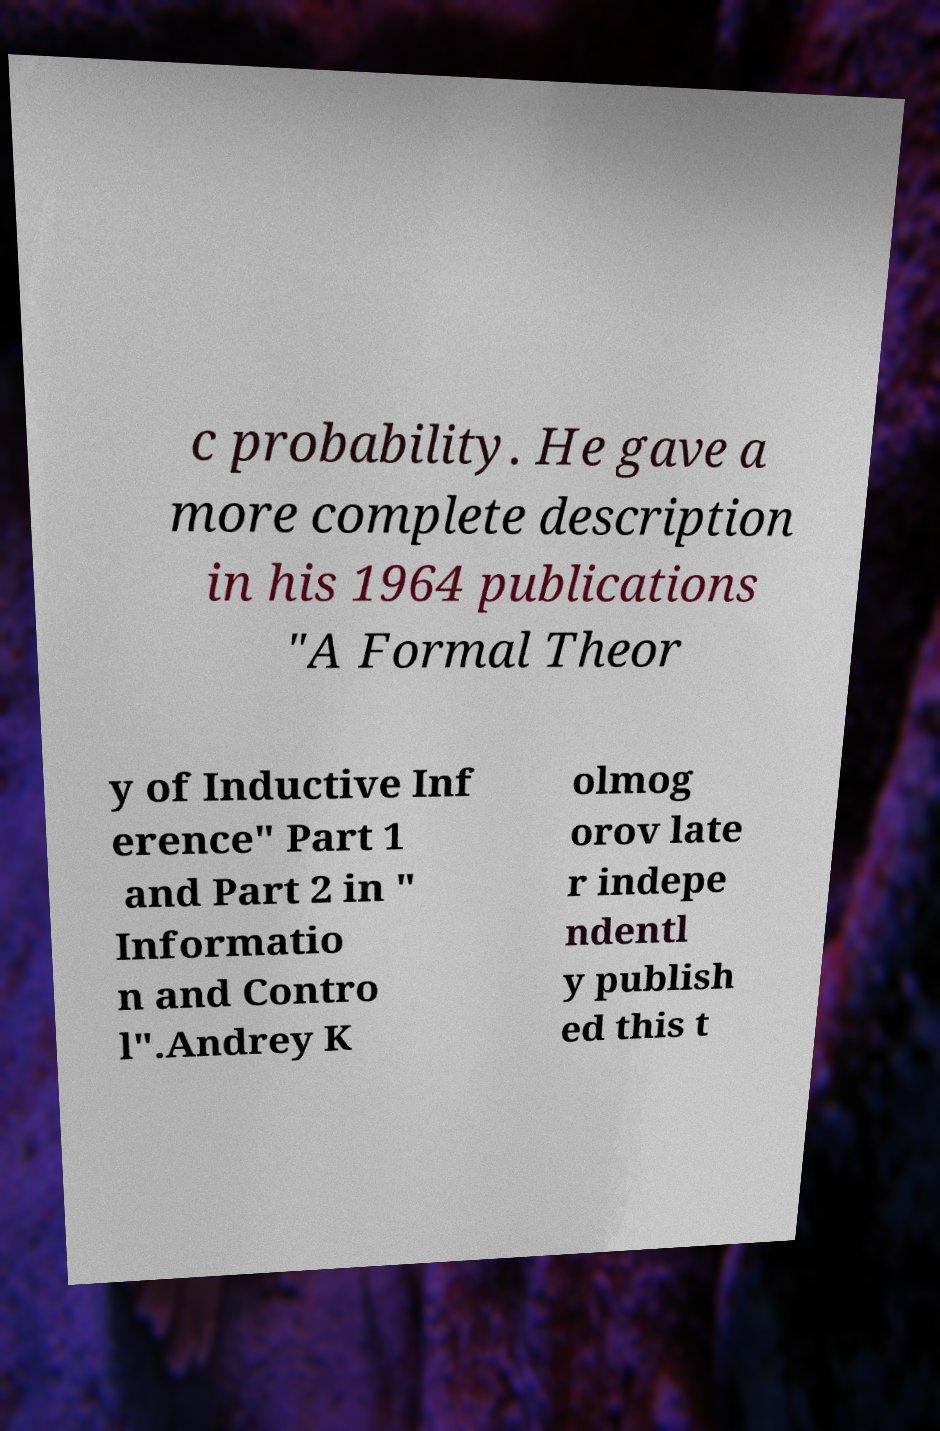Can you accurately transcribe the text from the provided image for me? c probability. He gave a more complete description in his 1964 publications "A Formal Theor y of Inductive Inf erence" Part 1 and Part 2 in " Informatio n and Contro l".Andrey K olmog orov late r indepe ndentl y publish ed this t 